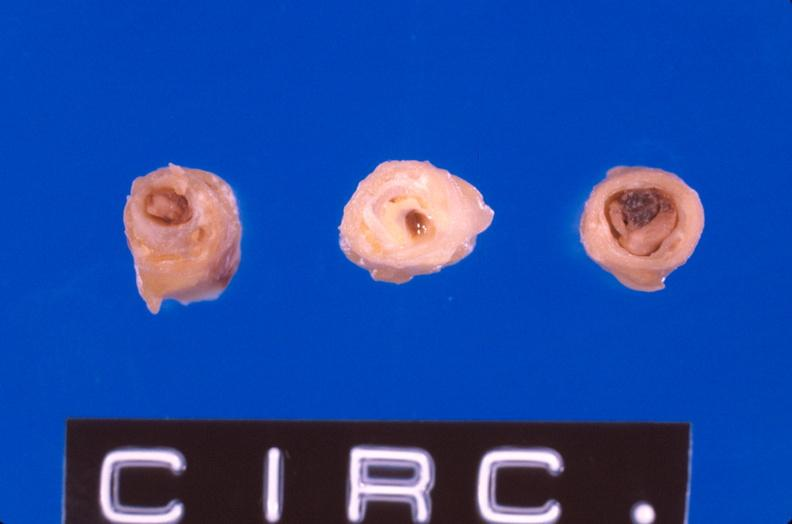s chronic ischemia present?
Answer the question using a single word or phrase. No 